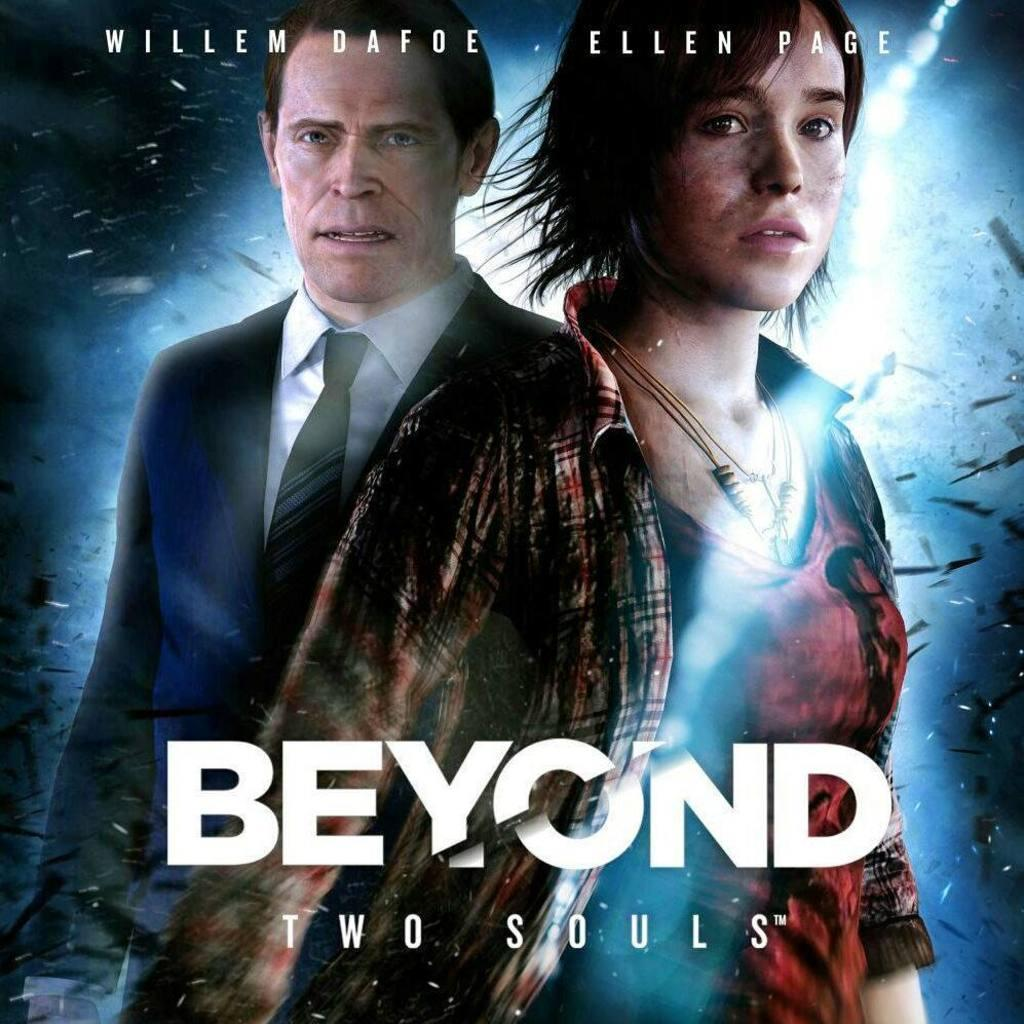What is the main subject of the poster in the image? The poster contains a picture of a man and a woman. What else can be seen on the poster besides the images of the man and woman? There is text written on the poster. What type of behavior is the porter exhibiting in the image? There is no porter present in the image, and therefore no behavior to observe. 